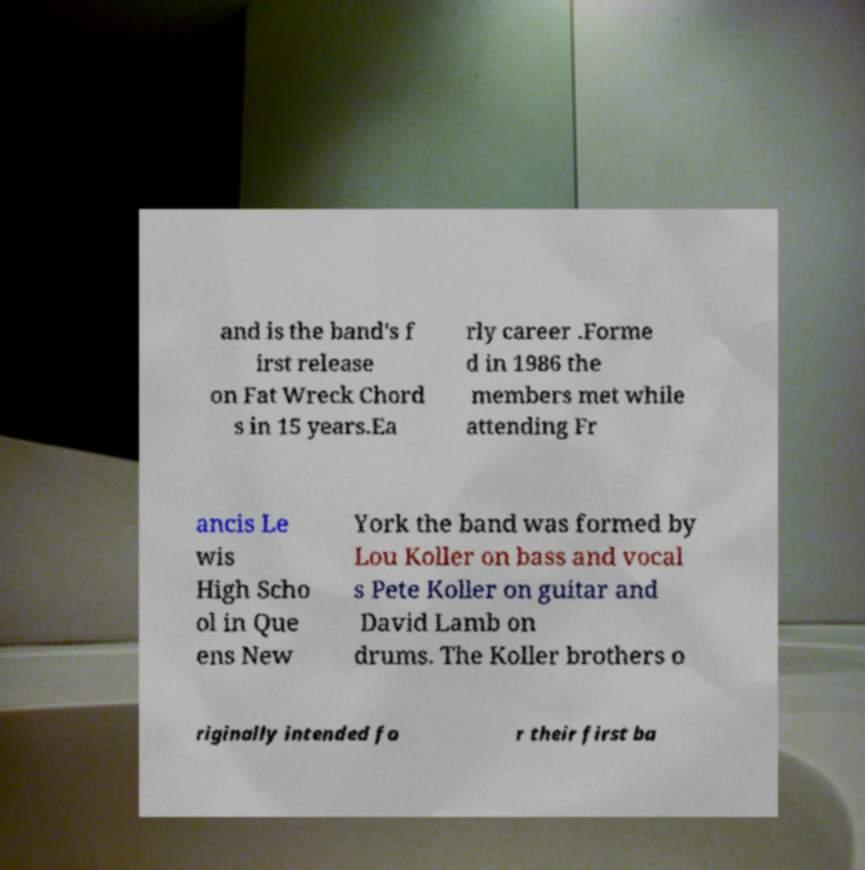Can you accurately transcribe the text from the provided image for me? and is the band's f irst release on Fat Wreck Chord s in 15 years.Ea rly career .Forme d in 1986 the members met while attending Fr ancis Le wis High Scho ol in Que ens New York the band was formed by Lou Koller on bass and vocal s Pete Koller on guitar and David Lamb on drums. The Koller brothers o riginally intended fo r their first ba 